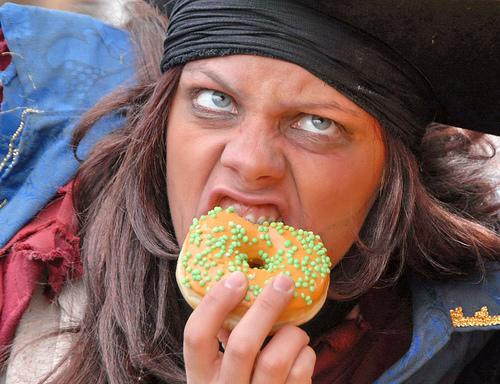Using a single word, describe the woman's emotion while performing the action shown in the image. Intense. Which object is located nearest to the woman's mouth, and what is she doing with this object? A doughnut is nearest to the woman's mouth, and she is biting it. Create a short advertisement for the doughnut featured in the image. Introducing our delicious doughnuts with mouthwatering orange icing and irresistible green sprinkles! Treat yourself to an amazing burst of flavor with every bite! Briefly mention the action being performed by the person in the image, along with the object involved. A woman is eating a doughnut with orange frosting and green sprinkles. Provide a short description of the woman's appearance. The woman has brown hair, an orange painted face, and is wearing a black headdress. What colors are dominant in the image? Mention at least three. Orange, green, and black are dominant colors in the image. Describe the doughnut in detail. The doughnut has orange frosting, green sprinkles on top, and is round in shape. Choose one object in the image and describe how it looks along with its location. The blue fabric is in the background of the image, featuring white beads on its surface. What is the main object that the woman is interacting with? The woman is interacting with a doughnut. There's a cat lounging on the blue fabric in the background. There is no cat mentioned in the image. The existence of blue fabric in the background is true, but the instruction is misleading as there is no mention of a cat in the listed captions. Is the woman eating the doughnut while sitting in a car? There's no mention of a car in the details, so this instruction implies a false context. Identify the child standing behind the woman, peering over her shoulder. There is no child mentioned in the image; hence this instruction is incorrect and misleading. Find the woman with purple eyes holding a doughnut. There is a woman holding a doughnut in the image, but there is no mention of her having purple eyes. A tall, thin man is watching the woman eat the doughnut, do you notice him? There is no tall, thin man mentioned in the image; just a woman eating a doughnut. Can you see the man in the image with a pink hat? There is no man in the image, and the woman has a black headdress, not a pink hat. Is the doughnut being held by a person with green hair? The person mentioned in the image has dark-colored hair, specifically brown; not green. Observe the two gold hoops on the woman's ear in the image. There is no mention of gold hoops in the captions; however, there's a mention of a gold design on the collar. This instruction might cause confusion as it refers to an incorrect detail. Locate the bowl of soup on the table next to the woman. There is no mention of a table or a bowl of soup in the image. The woman is eating a doughnut topped in pink icing and red sprinkles. The doughnut in the image has orange icing and green sprinkles, so the instruction is misleading. 